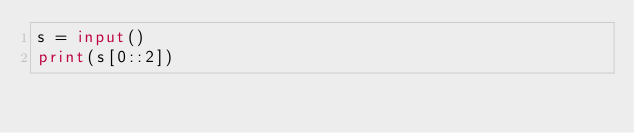Convert code to text. <code><loc_0><loc_0><loc_500><loc_500><_Python_>s = input()
print(s[0::2])
</code> 